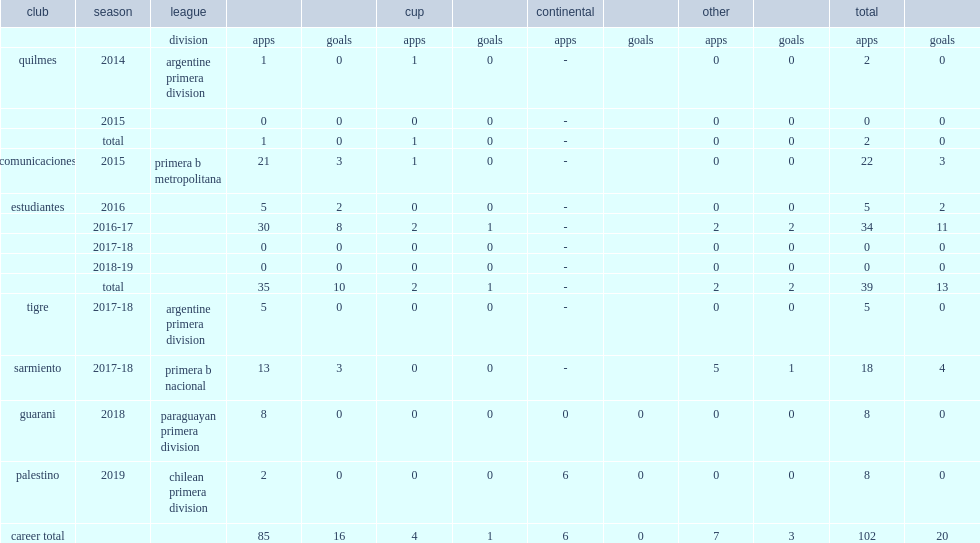Which club did passerini play for in 2016? Estudiantes. 